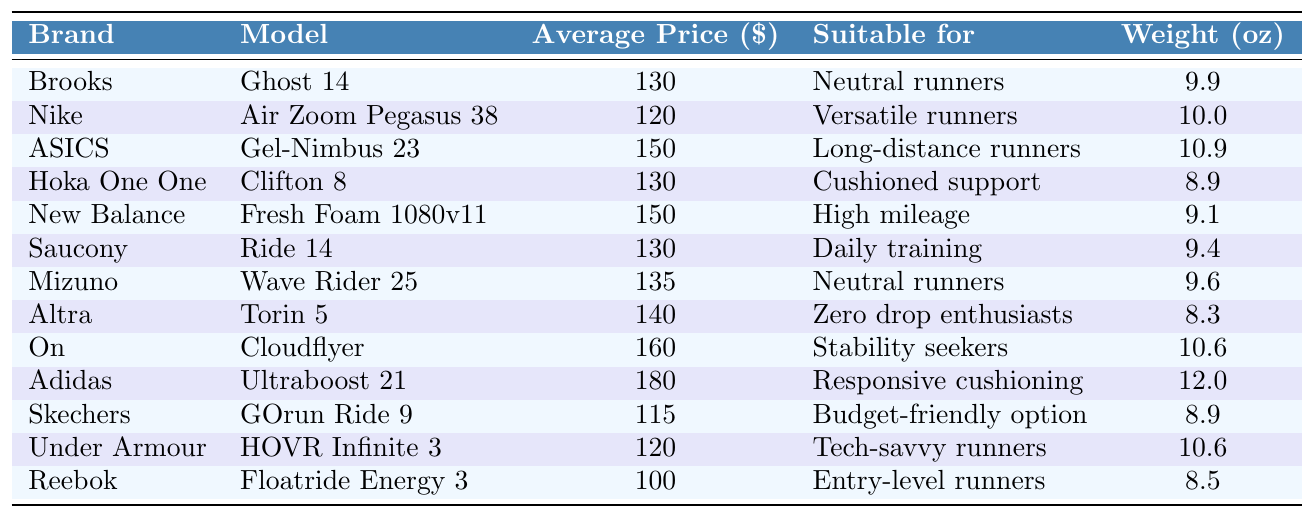What is the Average Price of the Adidas Ultraboost 21? According to the table, the average price listed for the Adidas Ultraboost 21 is $180.
Answer: $180 Which brand has the lightest shoe? By comparing the weight values, the Altra Torin 5 at 8.3 oz is lighter than all other brands listed.
Answer: Altra Are there any shoes suitable for long-distance runners under $150? The table shows that the ASICS Gel-Nimbus 23 is $150, which meets the upper limit. However, no shoes suitable for long-distance runners are listed below that price.
Answer: No How many brands have shoes priced at $130? The brands Brooks, Hoka One One, and Saucony all have shoes priced at $130, which totals three brands.
Answer: 3 What is the average price of the shoes offered by Mizuno and Altra? The Mizuno Wave Rider 25 costs $135 and the Altra Torin 5 costs $140. The average price is (135 + 140) / 2 = 137.5.
Answer: $137.5 Is the weight of the Skechers GOrun Ride 9 less than 9 oz? The table indicates that the weight of the Skechers GOrun Ride 9 is 8.9 oz, which is indeed less than 9 oz.
Answer: Yes Which brand's shoe is the most expensive and what is its price? The Adidas Ultraboost 21 is the most expensive shoe listed at a price of $180.
Answer: Adidas, $180 What is the price difference between the cheapest and most expensive shoe? The cheapest shoe is the Reebok Floatride Energy 3 at $100, while the most expensive is the Adidas Ultraboost 21 at $180. The price difference is 180 - 100 = 80.
Answer: $80 How many shoes are there suitable for neutral runners? The table lists Brookes Ghost 14 and Mizuno Wave Rider 25 as suitable for neutral runners, totaling two options.
Answer: 2 Which shoe has the highest weight and what is it? Looking at the weights, the Adidas Ultraboost 21 weighs 12.0 oz, which is the highest among the listed options.
Answer: Adidas Ultraboost 21, 12.0 oz 